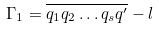<formula> <loc_0><loc_0><loc_500><loc_500>\Gamma _ { 1 } = \overline { q _ { 1 } q _ { 2 } \dots q _ { s } q ^ { \prime } } - l</formula> 